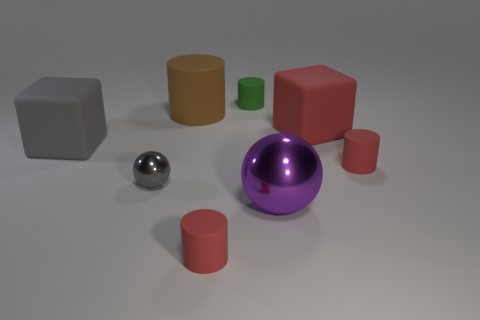There is a object that is the same color as the tiny shiny sphere; what is its material?
Provide a short and direct response. Rubber. How many other things are the same shape as the big brown thing?
Offer a very short reply. 3. What is the color of the cylinder that is the same size as the purple object?
Keep it short and to the point. Brown. Are there the same number of big brown rubber things to the right of the large purple metal ball and small rubber things in front of the big gray thing?
Give a very brief answer. No. What color is the large object that is both right of the gray block and in front of the red block?
Make the answer very short. Purple. The purple thing has what shape?
Make the answer very short. Sphere. How many other things are there of the same material as the gray cube?
Ensure brevity in your answer.  5. What is the size of the other gray shiny object that is the same shape as the big metallic object?
Ensure brevity in your answer.  Small. There is a tiny object behind the red rubber cylinder that is behind the tiny red object that is in front of the large purple ball; what is its material?
Provide a succinct answer. Rubber. Are there any small green rubber blocks?
Make the answer very short. No. 